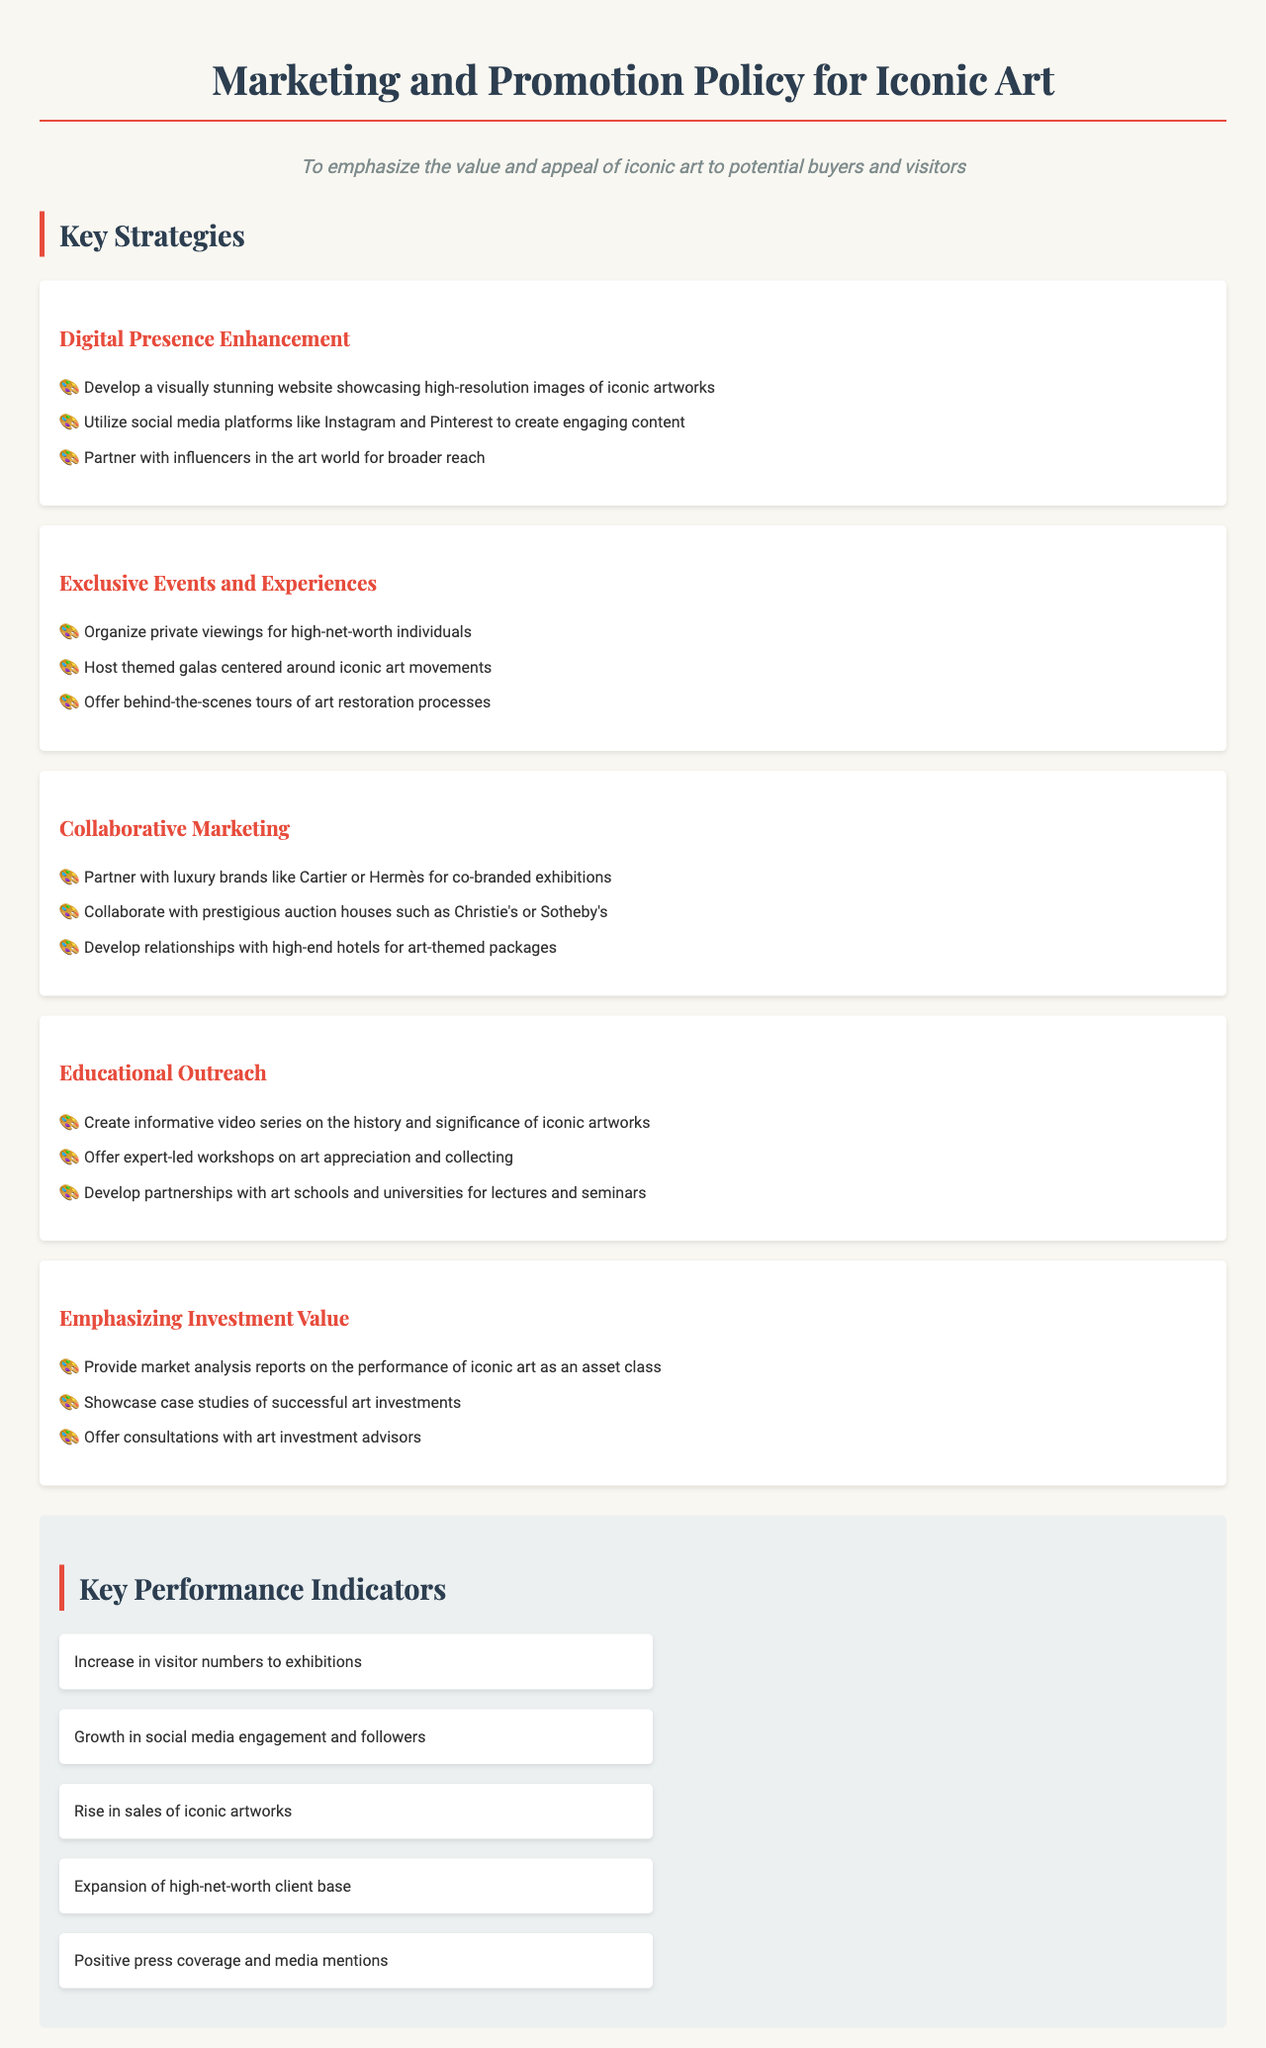What is the objective of the policy? The objective of the policy is to emphasize the value and appeal of iconic art to potential buyers and visitors.
Answer: To emphasize the value and appeal of iconic art to potential buyers and visitors How many key strategies are listed in the document? The document lists five key strategies aimed at enhancing marketing and promotion for iconic art.
Answer: Five Which social media platforms are suggested for engaging content? The document suggests utilizing platforms like Instagram and Pinterest for engaging content.
Answer: Instagram and Pinterest What type of events are proposed to attract high-net-worth individuals? The proposed events to attract high-net-worth individuals include organizing private viewings.
Answer: Private viewings Which luxury brand is mentioned for collaborative marketing? The document mentions partnering with luxury brand Cartier for co-branded exhibitions.
Answer: Cartier What kind of workshops are suggested under Educational Outreach? The document suggests offering expert-led workshops on art appreciation and collecting.
Answer: Art appreciation and collecting What is one key performance indicator mentioned? One of the key performance indicators mentioned is the increase in visitor numbers to exhibitions.
Answer: Increase in visitor numbers to exhibitions What should be showcased to emphasize the investment value? The document specifies showcasing case studies of successful art investments to emphasize investment value.
Answer: Case studies of successful art investments What is the significance of partnerships with art schools? The partnerships with art schools and universities are aimed at developing lectures and seminars in the Educational Outreach strategy.
Answer: Developing lectures and seminars 